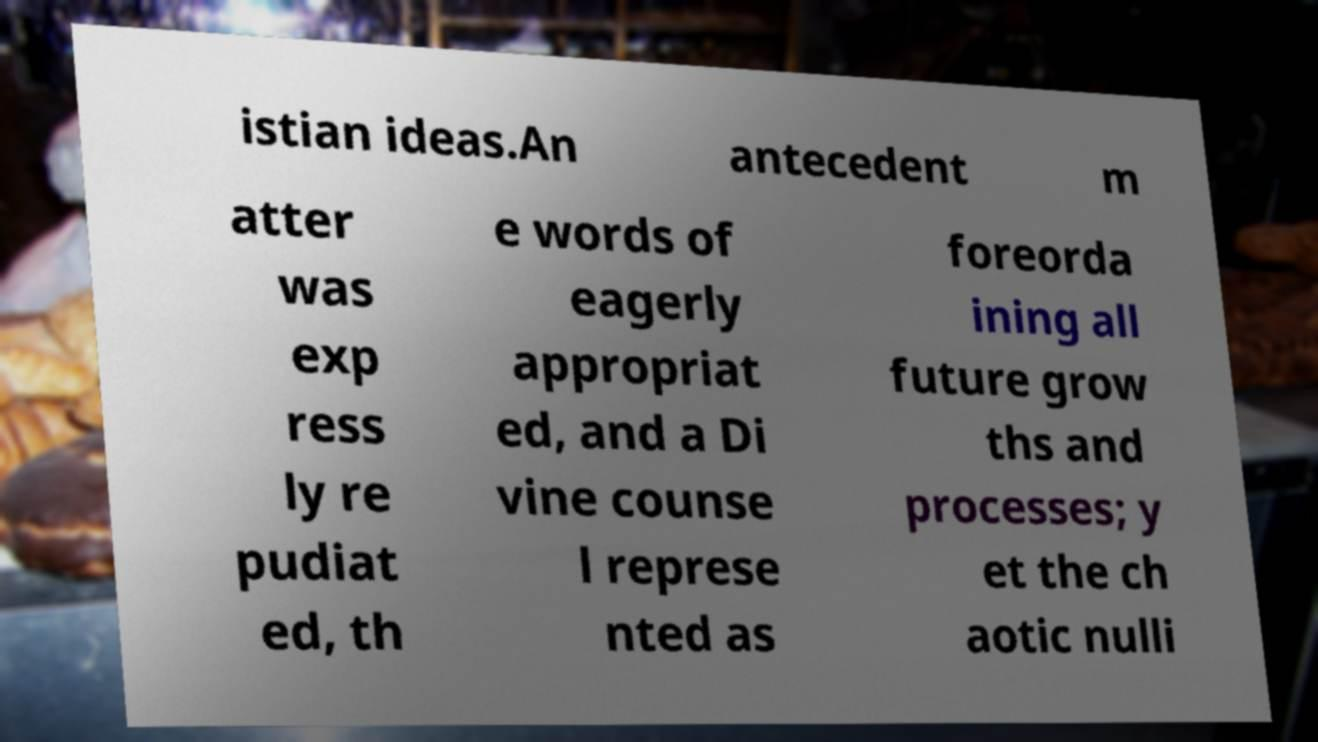Please identify and transcribe the text found in this image. istian ideas.An antecedent m atter was exp ress ly re pudiat ed, th e words of eagerly appropriat ed, and a Di vine counse l represe nted as foreorda ining all future grow ths and processes; y et the ch aotic nulli 